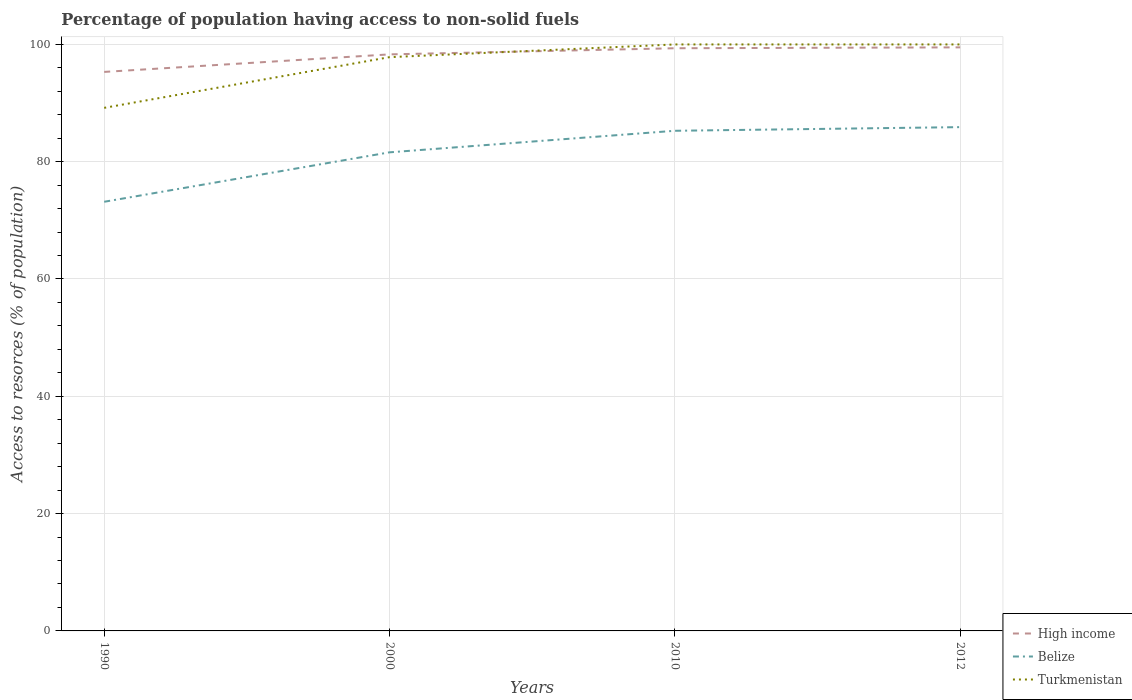Is the number of lines equal to the number of legend labels?
Offer a terse response. Yes. Across all years, what is the maximum percentage of population having access to non-solid fuels in Belize?
Provide a succinct answer. 73.17. In which year was the percentage of population having access to non-solid fuels in High income maximum?
Keep it short and to the point. 1990. What is the total percentage of population having access to non-solid fuels in Belize in the graph?
Your answer should be very brief. -3.67. What is the difference between the highest and the second highest percentage of population having access to non-solid fuels in Belize?
Give a very brief answer. 12.73. What is the difference between the highest and the lowest percentage of population having access to non-solid fuels in Belize?
Offer a terse response. 3. Is the percentage of population having access to non-solid fuels in Belize strictly greater than the percentage of population having access to non-solid fuels in Turkmenistan over the years?
Give a very brief answer. Yes. How many lines are there?
Offer a very short reply. 3. What is the difference between two consecutive major ticks on the Y-axis?
Ensure brevity in your answer.  20. Does the graph contain any zero values?
Provide a short and direct response. No. Does the graph contain grids?
Offer a very short reply. Yes. How many legend labels are there?
Offer a very short reply. 3. How are the legend labels stacked?
Keep it short and to the point. Vertical. What is the title of the graph?
Keep it short and to the point. Percentage of population having access to non-solid fuels. What is the label or title of the X-axis?
Your answer should be compact. Years. What is the label or title of the Y-axis?
Your answer should be compact. Access to resorces (% of population). What is the Access to resorces (% of population) in High income in 1990?
Provide a succinct answer. 95.31. What is the Access to resorces (% of population) in Belize in 1990?
Your response must be concise. 73.17. What is the Access to resorces (% of population) of Turkmenistan in 1990?
Offer a terse response. 89.18. What is the Access to resorces (% of population) of High income in 2000?
Provide a short and direct response. 98.3. What is the Access to resorces (% of population) in Belize in 2000?
Make the answer very short. 81.6. What is the Access to resorces (% of population) in Turkmenistan in 2000?
Your answer should be very brief. 97.82. What is the Access to resorces (% of population) in High income in 2010?
Your answer should be compact. 99.34. What is the Access to resorces (% of population) of Belize in 2010?
Keep it short and to the point. 85.27. What is the Access to resorces (% of population) in Turkmenistan in 2010?
Offer a very short reply. 99.99. What is the Access to resorces (% of population) in High income in 2012?
Provide a short and direct response. 99.49. What is the Access to resorces (% of population) of Belize in 2012?
Ensure brevity in your answer.  85.89. What is the Access to resorces (% of population) of Turkmenistan in 2012?
Your answer should be very brief. 99.99. Across all years, what is the maximum Access to resorces (% of population) of High income?
Your answer should be compact. 99.49. Across all years, what is the maximum Access to resorces (% of population) in Belize?
Make the answer very short. 85.89. Across all years, what is the maximum Access to resorces (% of population) of Turkmenistan?
Provide a short and direct response. 99.99. Across all years, what is the minimum Access to resorces (% of population) in High income?
Your answer should be very brief. 95.31. Across all years, what is the minimum Access to resorces (% of population) of Belize?
Your answer should be very brief. 73.17. Across all years, what is the minimum Access to resorces (% of population) in Turkmenistan?
Ensure brevity in your answer.  89.18. What is the total Access to resorces (% of population) of High income in the graph?
Ensure brevity in your answer.  392.44. What is the total Access to resorces (% of population) in Belize in the graph?
Offer a very short reply. 325.93. What is the total Access to resorces (% of population) in Turkmenistan in the graph?
Your answer should be compact. 386.98. What is the difference between the Access to resorces (% of population) in High income in 1990 and that in 2000?
Make the answer very short. -2.99. What is the difference between the Access to resorces (% of population) of Belize in 1990 and that in 2000?
Offer a very short reply. -8.43. What is the difference between the Access to resorces (% of population) in Turkmenistan in 1990 and that in 2000?
Your answer should be compact. -8.64. What is the difference between the Access to resorces (% of population) of High income in 1990 and that in 2010?
Your answer should be very brief. -4.04. What is the difference between the Access to resorces (% of population) of Belize in 1990 and that in 2010?
Provide a short and direct response. -12.1. What is the difference between the Access to resorces (% of population) in Turkmenistan in 1990 and that in 2010?
Offer a very short reply. -10.81. What is the difference between the Access to resorces (% of population) of High income in 1990 and that in 2012?
Keep it short and to the point. -4.19. What is the difference between the Access to resorces (% of population) of Belize in 1990 and that in 2012?
Offer a very short reply. -12.73. What is the difference between the Access to resorces (% of population) in Turkmenistan in 1990 and that in 2012?
Your response must be concise. -10.81. What is the difference between the Access to resorces (% of population) in High income in 2000 and that in 2010?
Ensure brevity in your answer.  -1.04. What is the difference between the Access to resorces (% of population) in Belize in 2000 and that in 2010?
Provide a succinct answer. -3.67. What is the difference between the Access to resorces (% of population) of Turkmenistan in 2000 and that in 2010?
Offer a terse response. -2.17. What is the difference between the Access to resorces (% of population) in High income in 2000 and that in 2012?
Offer a very short reply. -1.2. What is the difference between the Access to resorces (% of population) in Belize in 2000 and that in 2012?
Keep it short and to the point. -4.3. What is the difference between the Access to resorces (% of population) of Turkmenistan in 2000 and that in 2012?
Provide a succinct answer. -2.17. What is the difference between the Access to resorces (% of population) in High income in 2010 and that in 2012?
Your response must be concise. -0.15. What is the difference between the Access to resorces (% of population) of Belize in 2010 and that in 2012?
Your answer should be compact. -0.62. What is the difference between the Access to resorces (% of population) in Turkmenistan in 2010 and that in 2012?
Your answer should be compact. 0. What is the difference between the Access to resorces (% of population) of High income in 1990 and the Access to resorces (% of population) of Belize in 2000?
Your response must be concise. 13.71. What is the difference between the Access to resorces (% of population) of High income in 1990 and the Access to resorces (% of population) of Turkmenistan in 2000?
Provide a succinct answer. -2.51. What is the difference between the Access to resorces (% of population) of Belize in 1990 and the Access to resorces (% of population) of Turkmenistan in 2000?
Give a very brief answer. -24.65. What is the difference between the Access to resorces (% of population) in High income in 1990 and the Access to resorces (% of population) in Belize in 2010?
Keep it short and to the point. 10.04. What is the difference between the Access to resorces (% of population) in High income in 1990 and the Access to resorces (% of population) in Turkmenistan in 2010?
Offer a very short reply. -4.68. What is the difference between the Access to resorces (% of population) of Belize in 1990 and the Access to resorces (% of population) of Turkmenistan in 2010?
Your answer should be compact. -26.82. What is the difference between the Access to resorces (% of population) of High income in 1990 and the Access to resorces (% of population) of Belize in 2012?
Keep it short and to the point. 9.41. What is the difference between the Access to resorces (% of population) of High income in 1990 and the Access to resorces (% of population) of Turkmenistan in 2012?
Give a very brief answer. -4.68. What is the difference between the Access to resorces (% of population) of Belize in 1990 and the Access to resorces (% of population) of Turkmenistan in 2012?
Give a very brief answer. -26.82. What is the difference between the Access to resorces (% of population) of High income in 2000 and the Access to resorces (% of population) of Belize in 2010?
Keep it short and to the point. 13.03. What is the difference between the Access to resorces (% of population) of High income in 2000 and the Access to resorces (% of population) of Turkmenistan in 2010?
Ensure brevity in your answer.  -1.69. What is the difference between the Access to resorces (% of population) of Belize in 2000 and the Access to resorces (% of population) of Turkmenistan in 2010?
Provide a succinct answer. -18.39. What is the difference between the Access to resorces (% of population) in High income in 2000 and the Access to resorces (% of population) in Belize in 2012?
Provide a succinct answer. 12.4. What is the difference between the Access to resorces (% of population) in High income in 2000 and the Access to resorces (% of population) in Turkmenistan in 2012?
Provide a short and direct response. -1.69. What is the difference between the Access to resorces (% of population) of Belize in 2000 and the Access to resorces (% of population) of Turkmenistan in 2012?
Provide a succinct answer. -18.39. What is the difference between the Access to resorces (% of population) in High income in 2010 and the Access to resorces (% of population) in Belize in 2012?
Your response must be concise. 13.45. What is the difference between the Access to resorces (% of population) in High income in 2010 and the Access to resorces (% of population) in Turkmenistan in 2012?
Give a very brief answer. -0.65. What is the difference between the Access to resorces (% of population) of Belize in 2010 and the Access to resorces (% of population) of Turkmenistan in 2012?
Keep it short and to the point. -14.72. What is the average Access to resorces (% of population) in High income per year?
Your answer should be very brief. 98.11. What is the average Access to resorces (% of population) in Belize per year?
Give a very brief answer. 81.48. What is the average Access to resorces (% of population) in Turkmenistan per year?
Your response must be concise. 96.74. In the year 1990, what is the difference between the Access to resorces (% of population) of High income and Access to resorces (% of population) of Belize?
Provide a short and direct response. 22.14. In the year 1990, what is the difference between the Access to resorces (% of population) in High income and Access to resorces (% of population) in Turkmenistan?
Your response must be concise. 6.13. In the year 1990, what is the difference between the Access to resorces (% of population) in Belize and Access to resorces (% of population) in Turkmenistan?
Provide a short and direct response. -16.01. In the year 2000, what is the difference between the Access to resorces (% of population) in High income and Access to resorces (% of population) in Belize?
Ensure brevity in your answer.  16.7. In the year 2000, what is the difference between the Access to resorces (% of population) of High income and Access to resorces (% of population) of Turkmenistan?
Provide a short and direct response. 0.48. In the year 2000, what is the difference between the Access to resorces (% of population) in Belize and Access to resorces (% of population) in Turkmenistan?
Provide a succinct answer. -16.23. In the year 2010, what is the difference between the Access to resorces (% of population) in High income and Access to resorces (% of population) in Belize?
Provide a succinct answer. 14.07. In the year 2010, what is the difference between the Access to resorces (% of population) of High income and Access to resorces (% of population) of Turkmenistan?
Provide a succinct answer. -0.65. In the year 2010, what is the difference between the Access to resorces (% of population) of Belize and Access to resorces (% of population) of Turkmenistan?
Your answer should be compact. -14.72. In the year 2012, what is the difference between the Access to resorces (% of population) in High income and Access to resorces (% of population) in Belize?
Make the answer very short. 13.6. In the year 2012, what is the difference between the Access to resorces (% of population) in High income and Access to resorces (% of population) in Turkmenistan?
Your answer should be compact. -0.5. In the year 2012, what is the difference between the Access to resorces (% of population) in Belize and Access to resorces (% of population) in Turkmenistan?
Your response must be concise. -14.1. What is the ratio of the Access to resorces (% of population) of High income in 1990 to that in 2000?
Your answer should be very brief. 0.97. What is the ratio of the Access to resorces (% of population) of Belize in 1990 to that in 2000?
Your answer should be compact. 0.9. What is the ratio of the Access to resorces (% of population) of Turkmenistan in 1990 to that in 2000?
Give a very brief answer. 0.91. What is the ratio of the Access to resorces (% of population) of High income in 1990 to that in 2010?
Ensure brevity in your answer.  0.96. What is the ratio of the Access to resorces (% of population) of Belize in 1990 to that in 2010?
Ensure brevity in your answer.  0.86. What is the ratio of the Access to resorces (% of population) in Turkmenistan in 1990 to that in 2010?
Your response must be concise. 0.89. What is the ratio of the Access to resorces (% of population) of High income in 1990 to that in 2012?
Ensure brevity in your answer.  0.96. What is the ratio of the Access to resorces (% of population) of Belize in 1990 to that in 2012?
Provide a short and direct response. 0.85. What is the ratio of the Access to resorces (% of population) in Turkmenistan in 1990 to that in 2012?
Offer a very short reply. 0.89. What is the ratio of the Access to resorces (% of population) of Belize in 2000 to that in 2010?
Ensure brevity in your answer.  0.96. What is the ratio of the Access to resorces (% of population) of Turkmenistan in 2000 to that in 2010?
Make the answer very short. 0.98. What is the ratio of the Access to resorces (% of population) in High income in 2000 to that in 2012?
Your answer should be very brief. 0.99. What is the ratio of the Access to resorces (% of population) of Turkmenistan in 2000 to that in 2012?
Your answer should be very brief. 0.98. What is the ratio of the Access to resorces (% of population) in Turkmenistan in 2010 to that in 2012?
Give a very brief answer. 1. What is the difference between the highest and the second highest Access to resorces (% of population) in High income?
Make the answer very short. 0.15. What is the difference between the highest and the second highest Access to resorces (% of population) of Belize?
Make the answer very short. 0.62. What is the difference between the highest and the second highest Access to resorces (% of population) of Turkmenistan?
Offer a very short reply. 0. What is the difference between the highest and the lowest Access to resorces (% of population) of High income?
Provide a succinct answer. 4.19. What is the difference between the highest and the lowest Access to resorces (% of population) in Belize?
Provide a short and direct response. 12.73. What is the difference between the highest and the lowest Access to resorces (% of population) in Turkmenistan?
Provide a succinct answer. 10.81. 